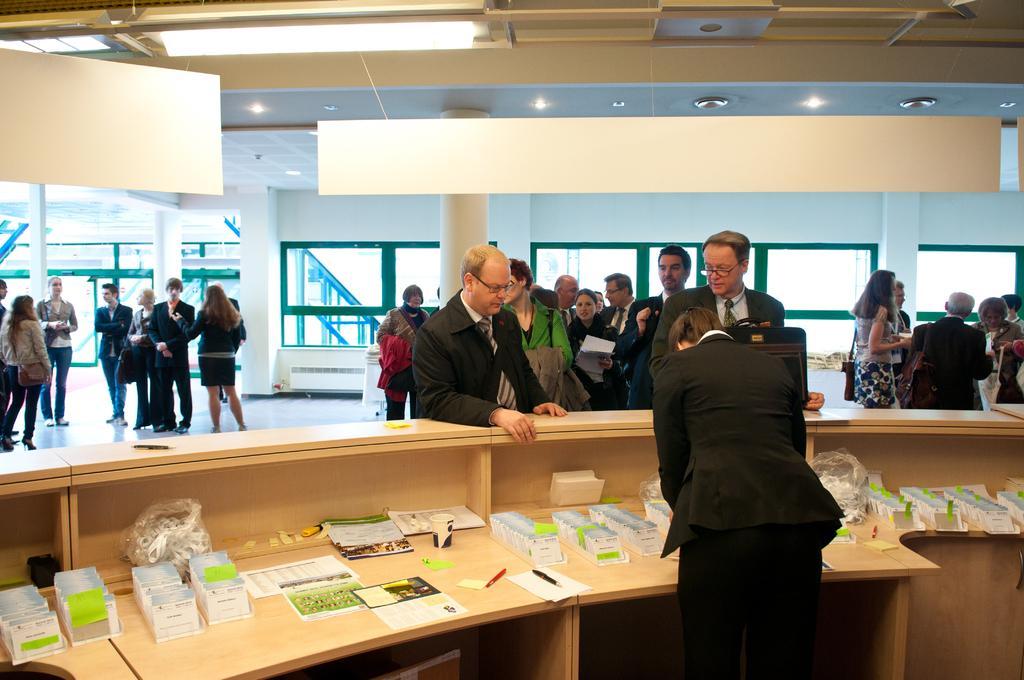Can you describe this image briefly? In this picture we can see cards, papers, glass, pens, plastic covers, tables, box, bags, spectacles and a group of people standing on the floor and in the background we can see the lights, pillars, windows and some objects. 